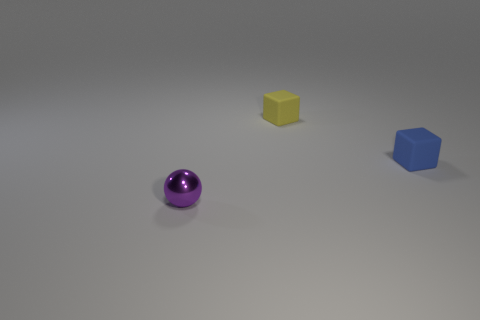There is a cube left of the small cube in front of the yellow thing; what size is it?
Offer a terse response. Small. What number of objects are small rubber things or shiny blocks?
Give a very brief answer. 2. Are there any small metal objects of the same color as the metallic ball?
Provide a succinct answer. No. Is the number of tiny purple spheres less than the number of matte blocks?
Offer a terse response. Yes. How many things are brown objects or objects that are behind the purple metallic ball?
Your answer should be very brief. 2. Are there any big gray cylinders that have the same material as the purple object?
Keep it short and to the point. No. What material is the block that is the same size as the blue object?
Ensure brevity in your answer.  Rubber. There is a small cube in front of the block behind the blue object; what is its material?
Your answer should be compact. Rubber. Do the thing right of the small yellow thing and the metal thing have the same shape?
Offer a terse response. No. What color is the block that is made of the same material as the blue thing?
Offer a very short reply. Yellow. 